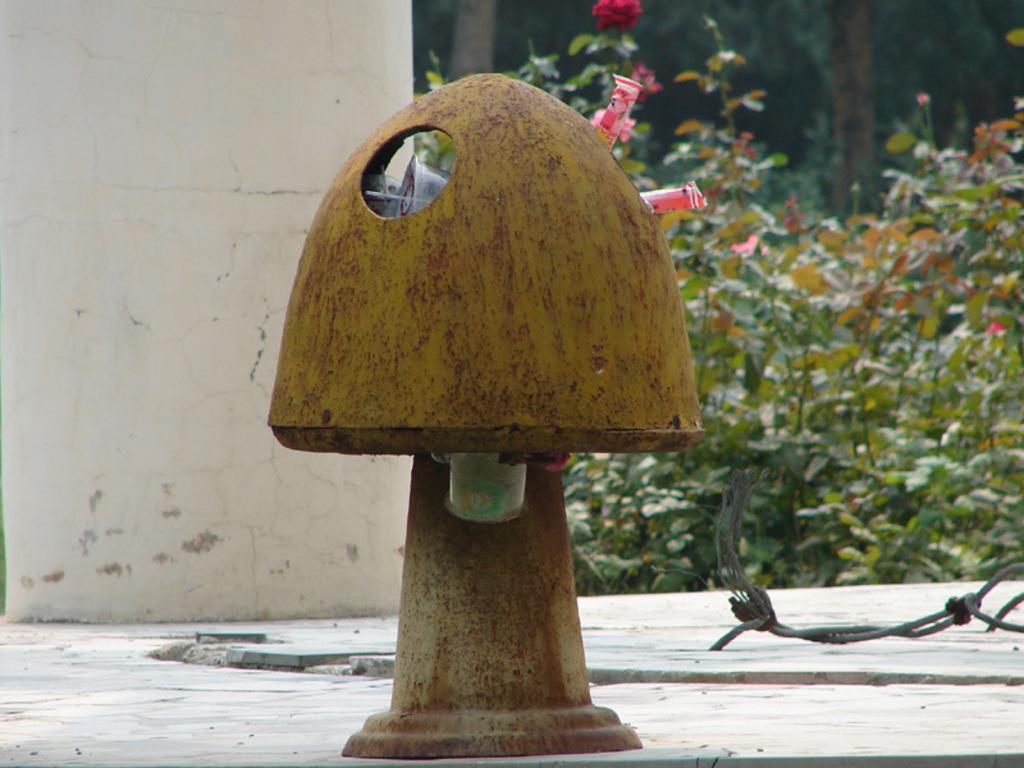Can you describe this image briefly? In the image there is dustbin on the land and on the left side there is a wall followed by plants behind it. 